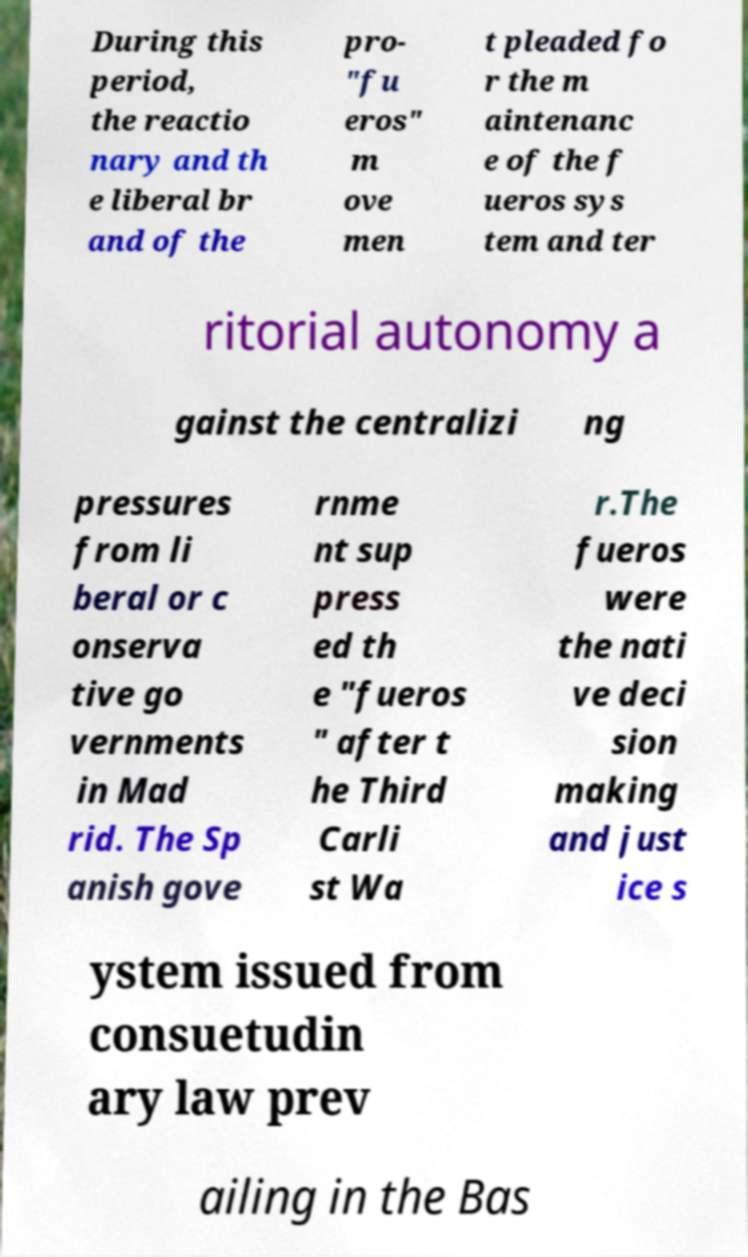Could you extract and type out the text from this image? During this period, the reactio nary and th e liberal br and of the pro- "fu eros" m ove men t pleaded fo r the m aintenanc e of the f ueros sys tem and ter ritorial autonomy a gainst the centralizi ng pressures from li beral or c onserva tive go vernments in Mad rid. The Sp anish gove rnme nt sup press ed th e "fueros " after t he Third Carli st Wa r.The fueros were the nati ve deci sion making and just ice s ystem issued from consuetudin ary law prev ailing in the Bas 